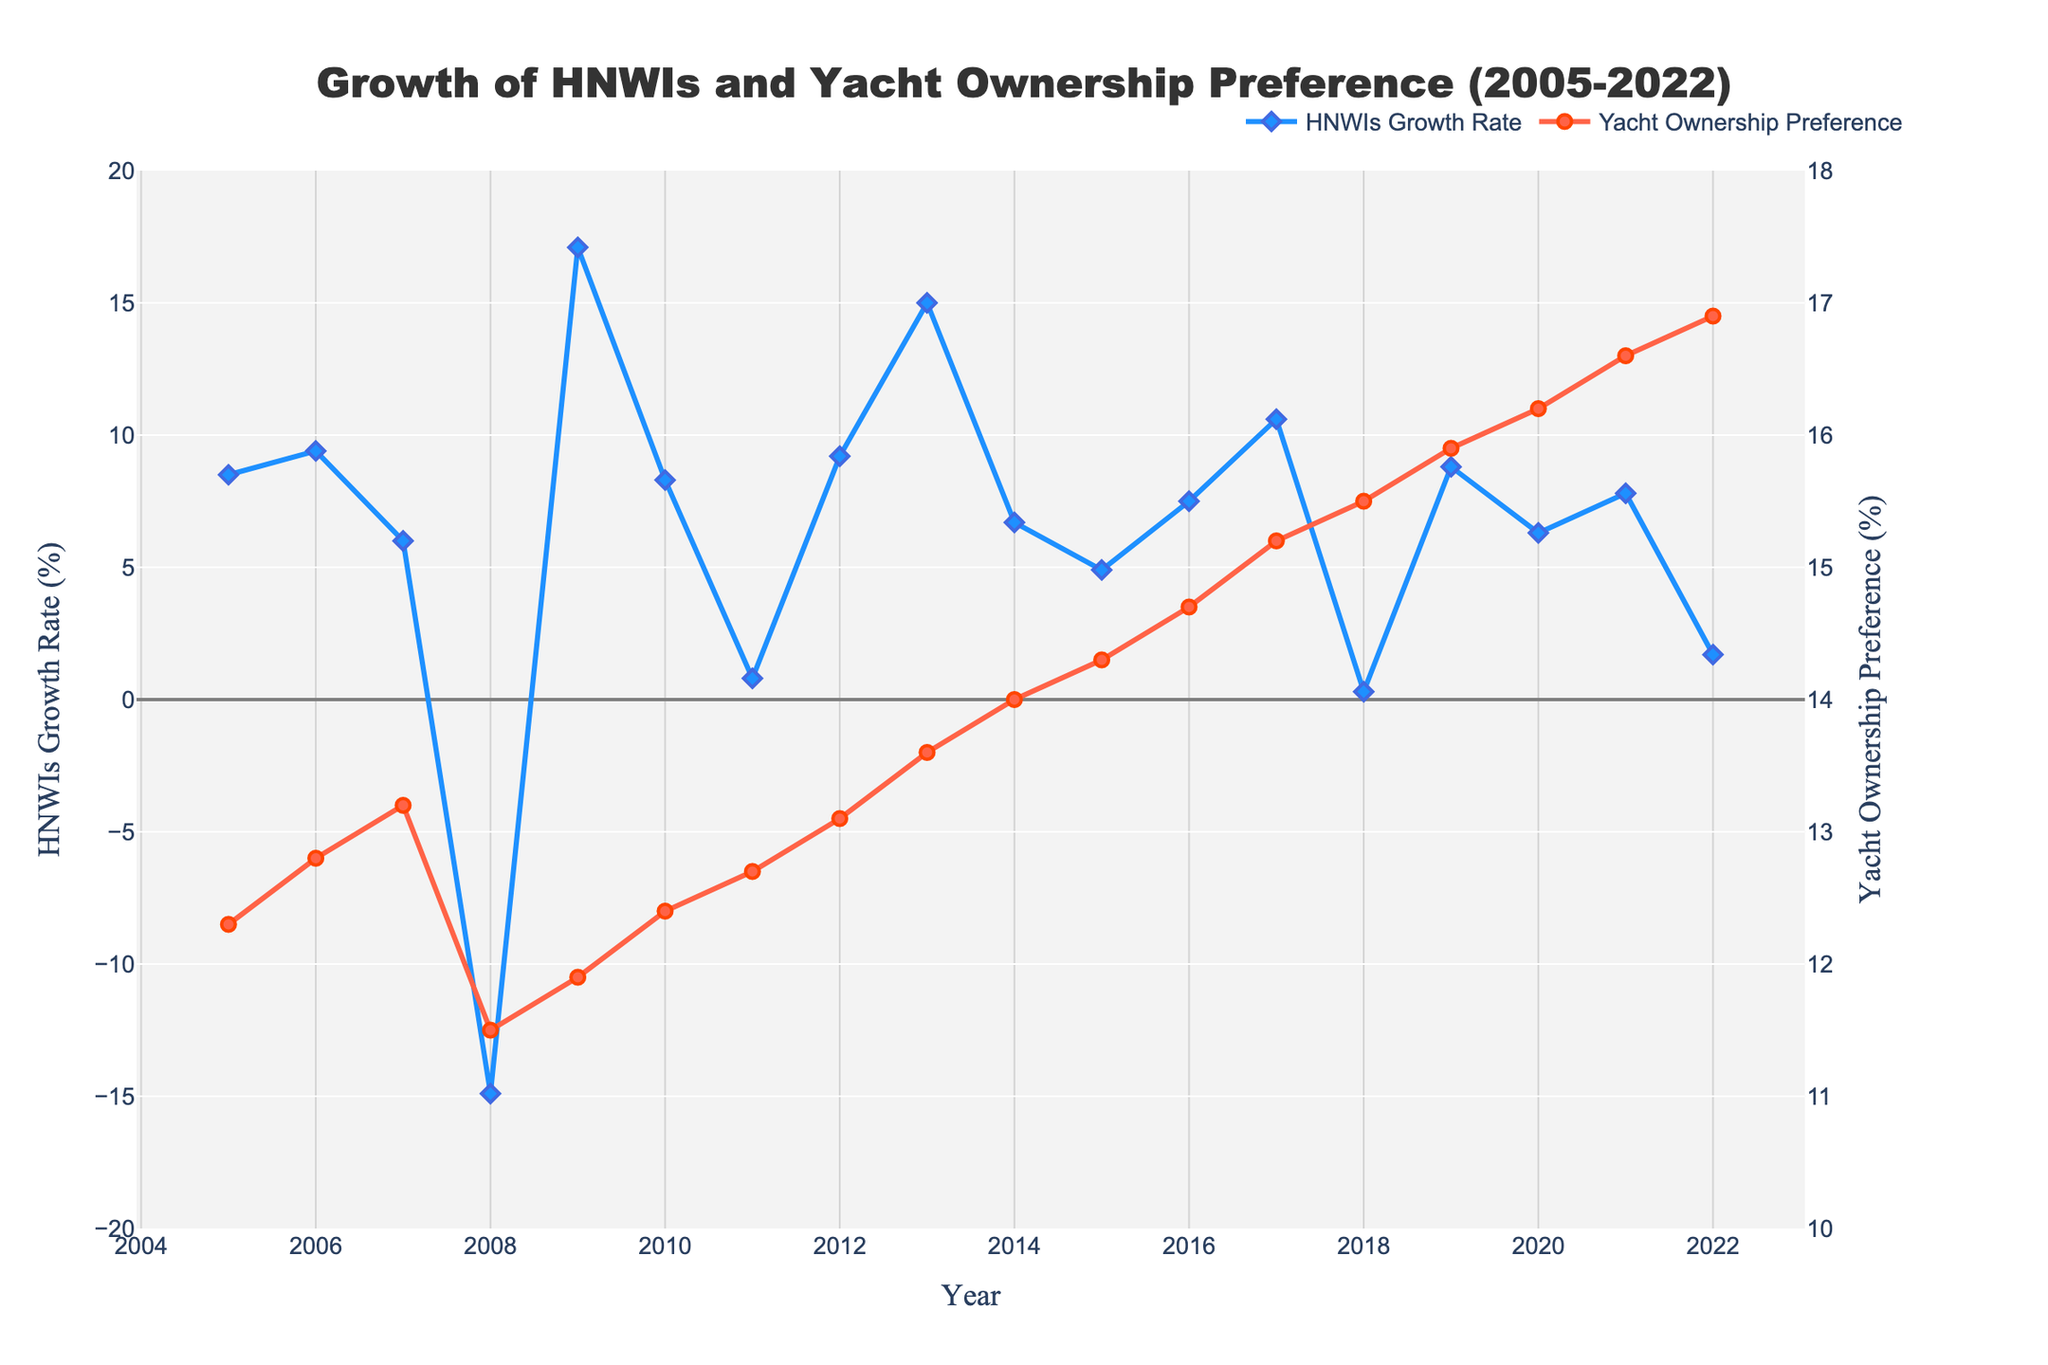How did the HNWIs Growth Rate and Yacht Ownership Preference change from 2008 to 2009? From the figure, the HNWIs Growth Rate saw a significant increase from -14.9% in 2008 to 17.1% in 2009. Yacht Ownership Preference had a slight increase from 11.5% to 11.9% during the same period.
Answer: HNWIs Growth Rate increased by 32%, Yacht Ownership Preference increased by 0.4% What's the trend in Yacht Ownership Preference between 2010 and 2022? Observing the figure, Yacht Ownership Preference consistently increased from 12.4% in 2010 to 16.9% in 2022, suggesting a positive upward trend over these years.
Answer: Consistent increase Which year had the lowest HNWIs Growth Rate and what was its corresponding Yacht Ownership Preference? The figure indicates that 2008 had the lowest HNWIs Growth Rate at -14.9%, and the corresponding Yacht Ownership Preference for that year was 11.5%.
Answer: 2008, 11.5% How do the HNWIs Growth Rate and Yacht Ownership Preference compare in the year 2017? In 2017, the HNWIs Growth Rate was 10.6% and Yacht Ownership Preference was 15.2% as per the figure.
Answer: 10.6%, 15.2% What's the difference in Yacht Ownership Preference between 2005 and 2022? From the figure, the Yacht Ownership Preference in 2005 was 12.3%, and it increased to 16.9% in 2022. The difference is 16.9% - 12.3% = 4.6%.
Answer: 4.6% Which data point in the Yacht Ownership Preference line has the highest value and in which year does it occur? The highest value in the Yacht Ownership Preference line is 16.9% in the year 2022 as shown in the figure.
Answer: 16.9%, 2022 In which year was the HNWIs Growth Rate exactly 0.3%, and what was the Yacht Ownership Preference that year? The figure shows that in 2018, the HNWIs Growth Rate was exactly 0.3%, and the Yacht Ownership Preference was 15.5%.
Answer: 2018, 15.5% Compare the trends of HNWIs Growth Rate and Yacht Ownership Preference from 2005 to 2022. By analyzing the figure, the HNWIs Growth Rate shows higher variability with noticeable peaks and drops while Yacht Ownership Preference shows a steady increasing trend over the same period.
Answer: Variable vs. Steadily Increasing Which year had the highest HNWIs Growth Rate and what was the Yacht Ownership Preference in that year? According to the figure, 2009 had the highest HNWIs Growth Rate of 17.1%, with a corresponding Yacht Ownership Preference of 11.9%.
Answer: 2009, 11.9% 